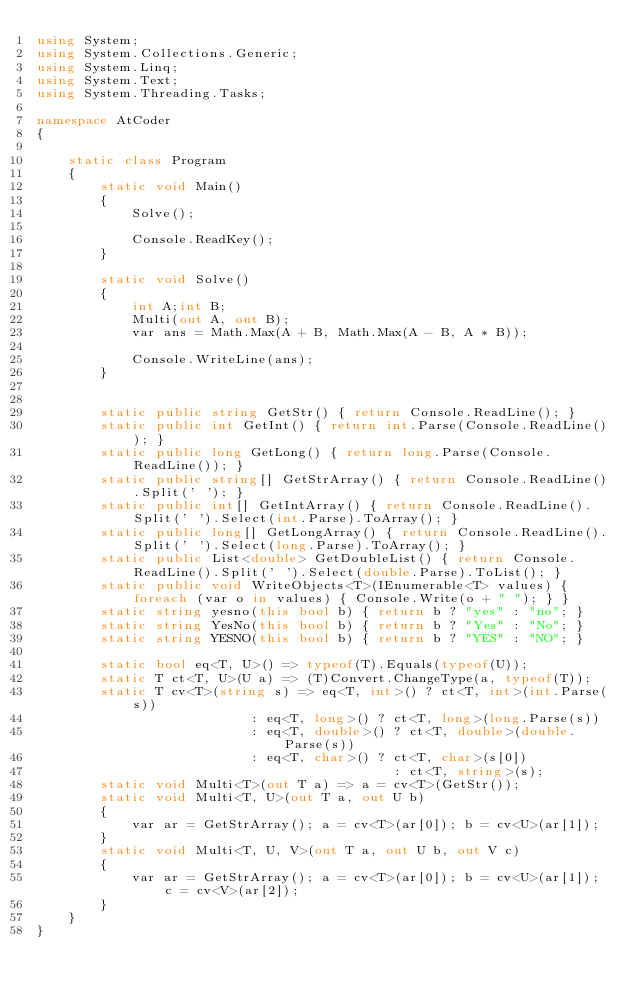<code> <loc_0><loc_0><loc_500><loc_500><_C#_>using System;
using System.Collections.Generic;
using System.Linq;
using System.Text;
using System.Threading.Tasks;

namespace AtCoder
{

    static class Program
    {
        static void Main()
        {
            Solve();

            Console.ReadKey();
        }

        static void Solve()
        {
            int A;int B;
            Multi(out A, out B);
            var ans = Math.Max(A + B, Math.Max(A - B, A * B));

            Console.WriteLine(ans);
        }


        static public string GetStr() { return Console.ReadLine(); }
        static public int GetInt() { return int.Parse(Console.ReadLine()); }
        static public long GetLong() { return long.Parse(Console.ReadLine()); }
        static public string[] GetStrArray() { return Console.ReadLine().Split(' '); }
        static public int[] GetIntArray() { return Console.ReadLine().Split(' ').Select(int.Parse).ToArray(); }
        static public long[] GetLongArray() { return Console.ReadLine().Split(' ').Select(long.Parse).ToArray(); }
        static public List<double> GetDoubleList() { return Console.ReadLine().Split(' ').Select(double.Parse).ToList(); }
        static public void WriteObjects<T>(IEnumerable<T> values) { foreach (var o in values) { Console.Write(o + " "); } }
        static string yesno(this bool b) { return b ? "yes" : "no"; }
        static string YesNo(this bool b) { return b ? "Yes" : "No"; }
        static string YESNO(this bool b) { return b ? "YES" : "NO"; }

        static bool eq<T, U>() => typeof(T).Equals(typeof(U));
        static T ct<T, U>(U a) => (T)Convert.ChangeType(a, typeof(T));
        static T cv<T>(string s) => eq<T, int>() ? ct<T, int>(int.Parse(s))
                           : eq<T, long>() ? ct<T, long>(long.Parse(s))
                           : eq<T, double>() ? ct<T, double>(double.Parse(s))
                           : eq<T, char>() ? ct<T, char>(s[0])
                                             : ct<T, string>(s);
        static void Multi<T>(out T a) => a = cv<T>(GetStr());
        static void Multi<T, U>(out T a, out U b)
        {
            var ar = GetStrArray(); a = cv<T>(ar[0]); b = cv<U>(ar[1]);
        }
        static void Multi<T, U, V>(out T a, out U b, out V c)
        {
            var ar = GetStrArray(); a = cv<T>(ar[0]); b = cv<U>(ar[1]); c = cv<V>(ar[2]);
        }
    }
}</code> 